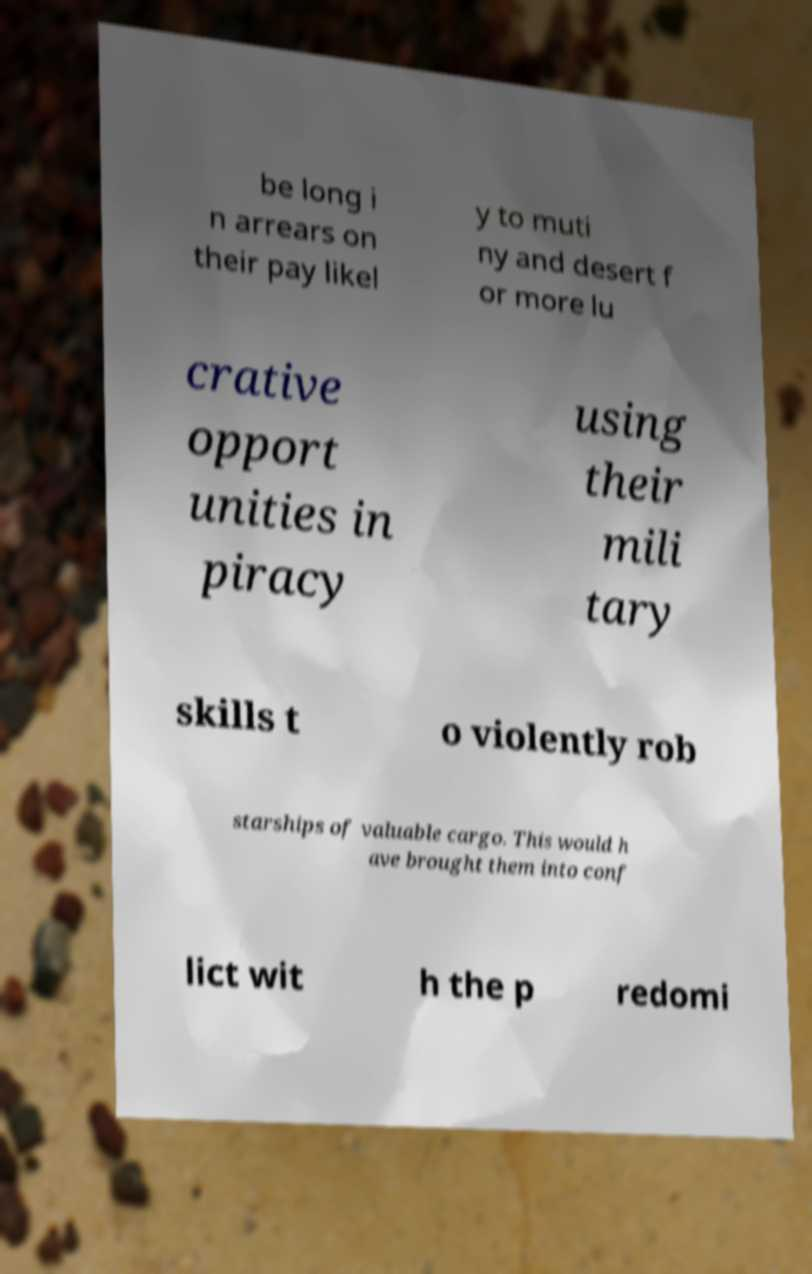I need the written content from this picture converted into text. Can you do that? be long i n arrears on their pay likel y to muti ny and desert f or more lu crative opport unities in piracy using their mili tary skills t o violently rob starships of valuable cargo. This would h ave brought them into conf lict wit h the p redomi 